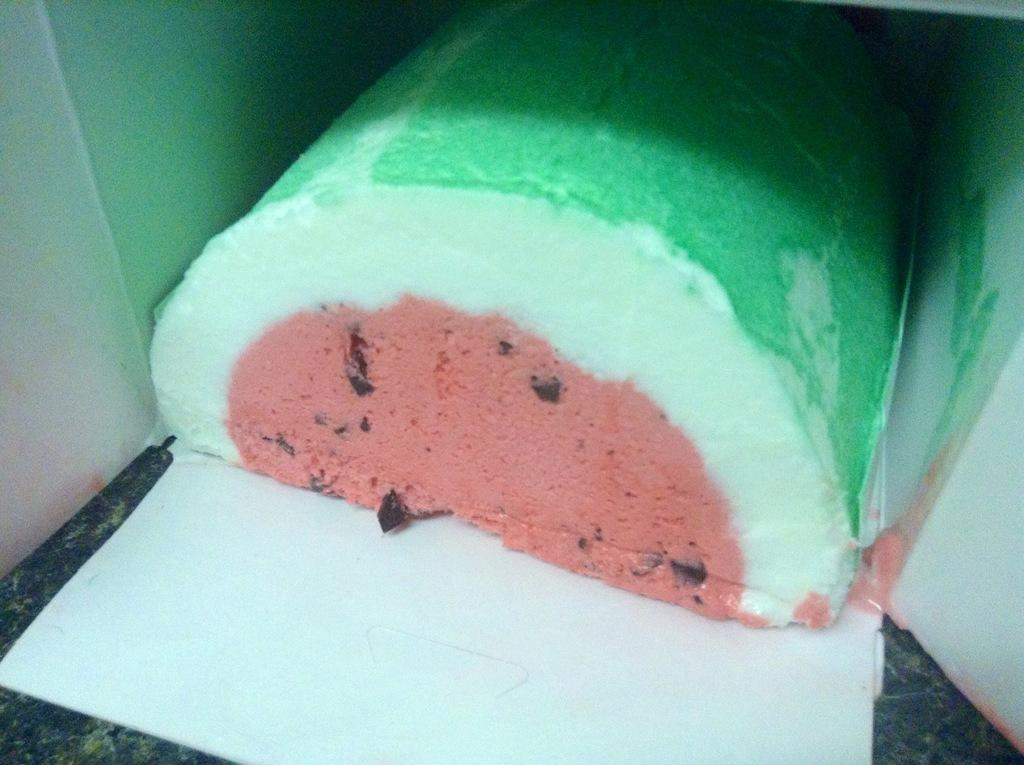What is the main subject in the image? There is a cake in the image. How is the cake being contained or protected? The cake is placed in a box. What is visible at the bottom of the image? There is a surface at the bottom of the image. What type of process is being carried out on the lizards in the image? There are no lizards present in the image, so no such process can be observed. What type of powder is sprinkled on top of the cake in the image? There is no powder visible on top of the cake in the image. 